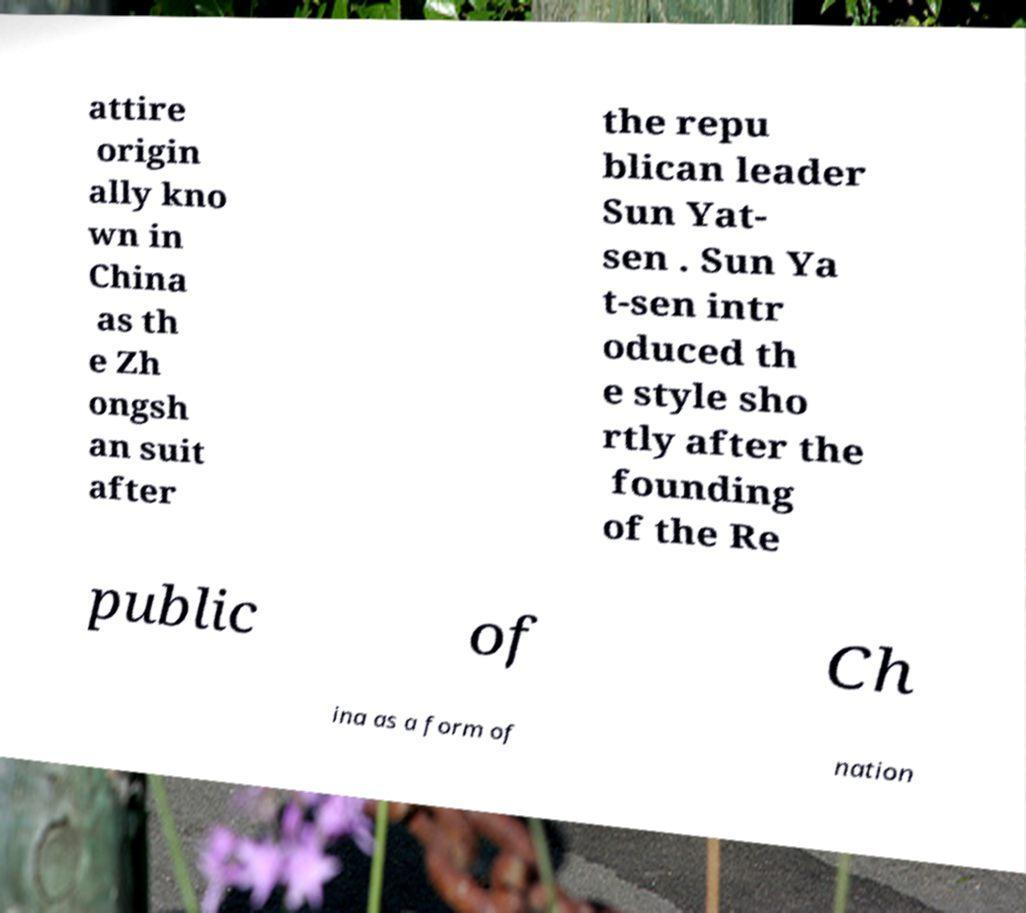Can you read and provide the text displayed in the image?This photo seems to have some interesting text. Can you extract and type it out for me? attire origin ally kno wn in China as th e Zh ongsh an suit after the repu blican leader Sun Yat- sen . Sun Ya t-sen intr oduced th e style sho rtly after the founding of the Re public of Ch ina as a form of nation 